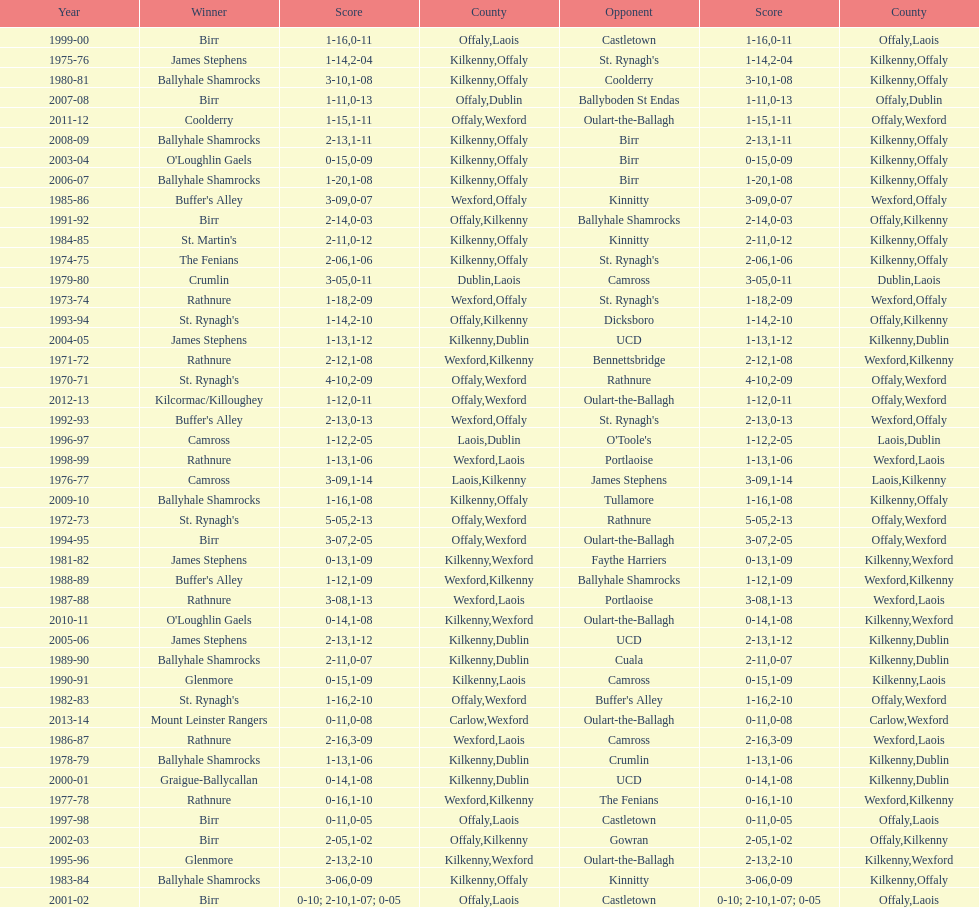What was the last season the leinster senior club hurling championships was won by a score differential of less than 11? 2007-08. 